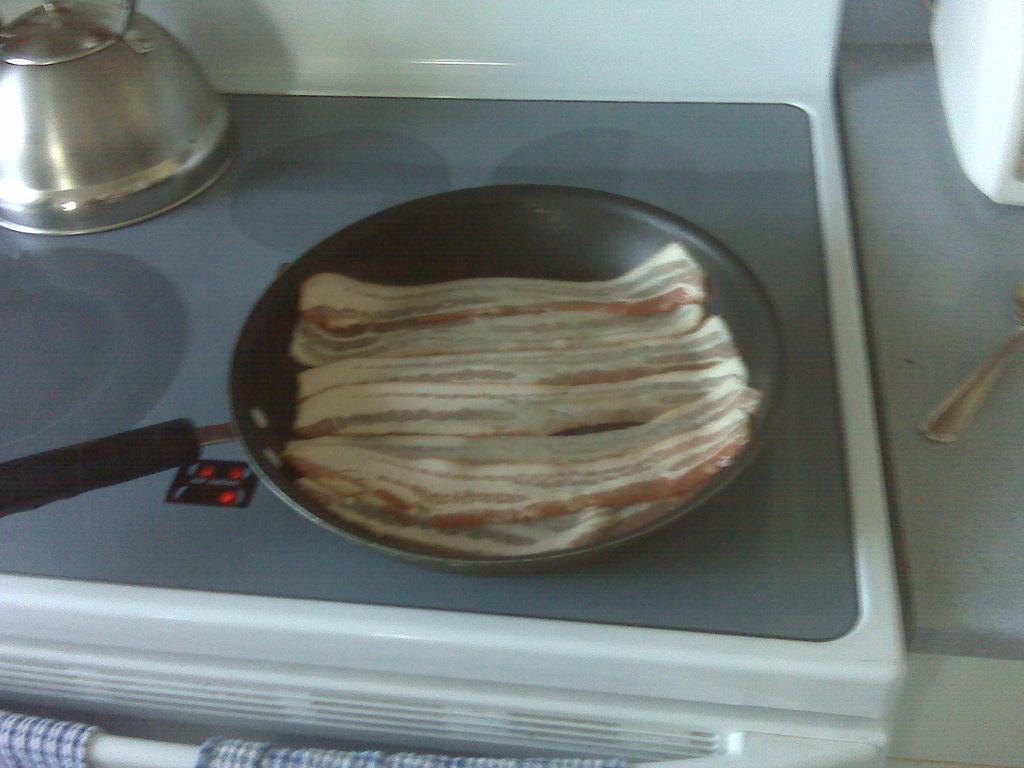How would you summarize this image in a sentence or two? This is a frying pan with a food, which is placed on the induction stove. This looks like a kettle. On the right side of the image, this looks like a spoon, which is placed on the table. At the bottom of the image, I think these are the clothes. 